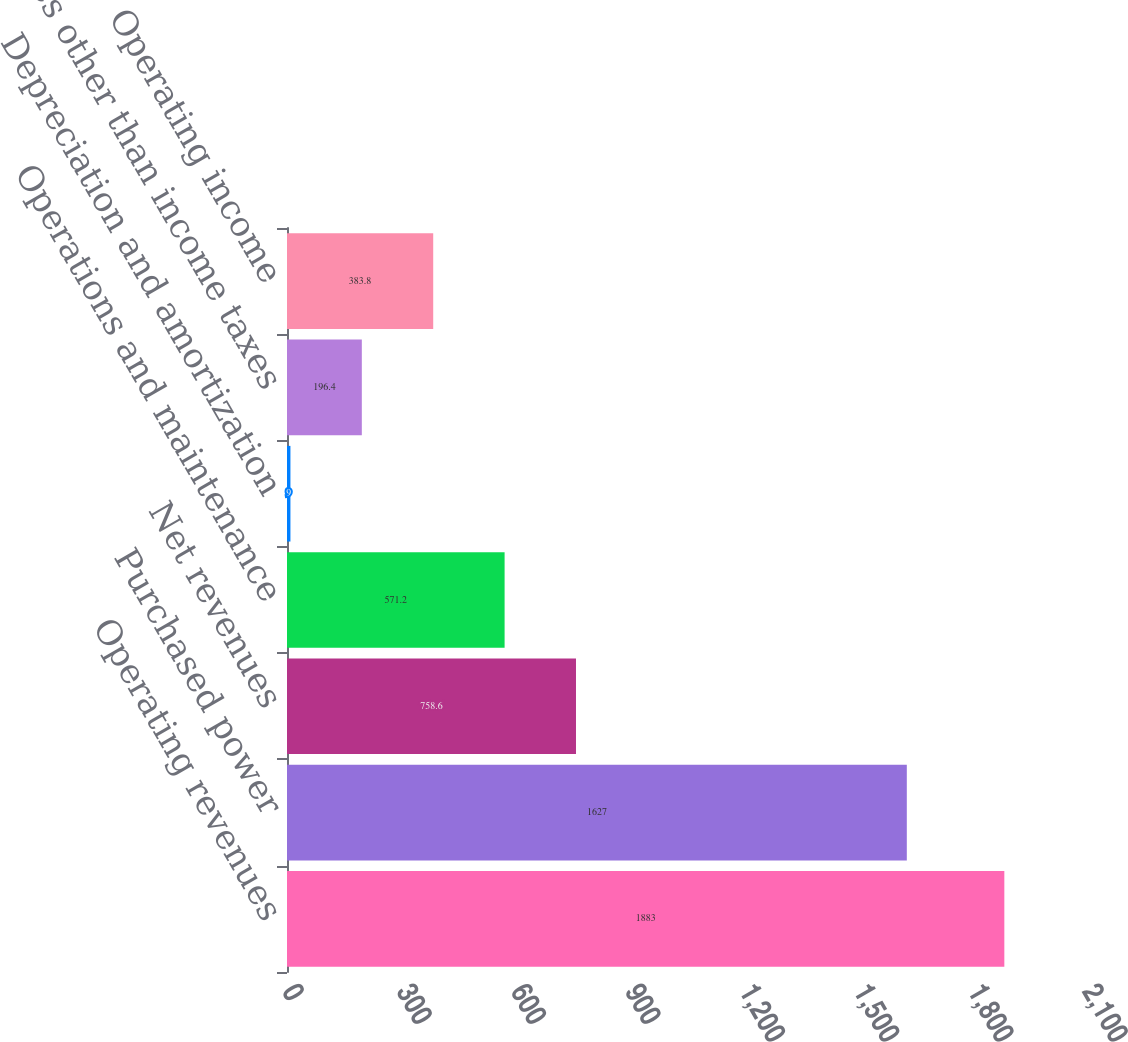Convert chart. <chart><loc_0><loc_0><loc_500><loc_500><bar_chart><fcel>Operating revenues<fcel>Purchased power<fcel>Net revenues<fcel>Operations and maintenance<fcel>Depreciation and amortization<fcel>Taxes other than income taxes<fcel>Operating income<nl><fcel>1883<fcel>1627<fcel>758.6<fcel>571.2<fcel>9<fcel>196.4<fcel>383.8<nl></chart> 